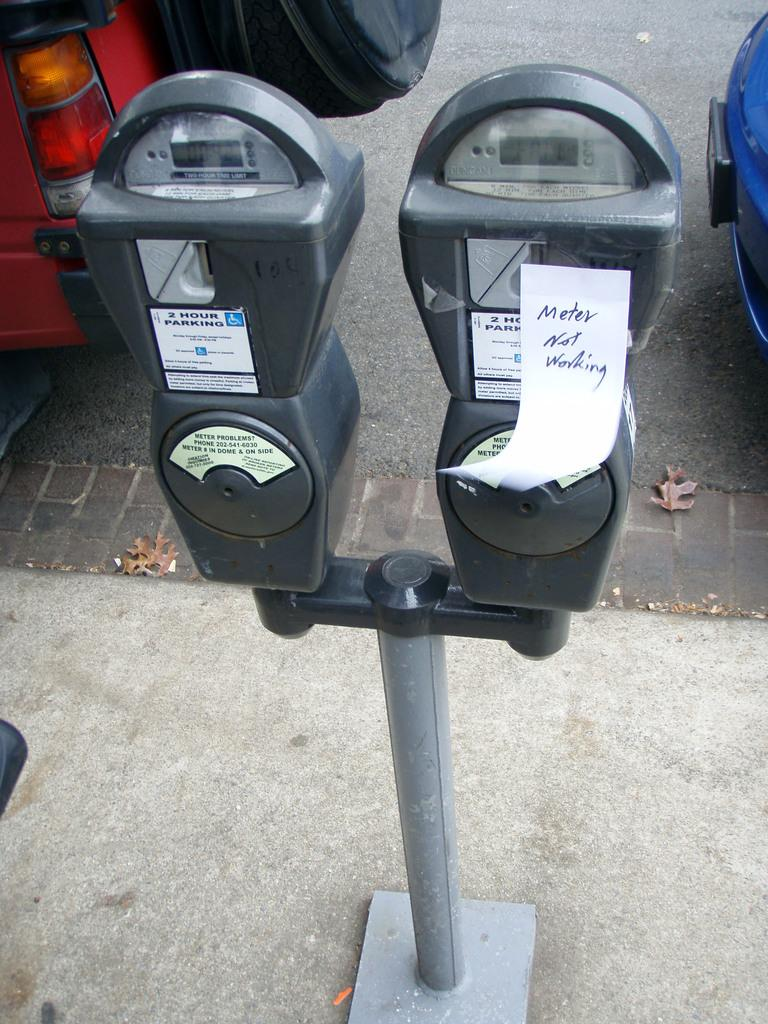<image>
Render a clear and concise summary of the photo. Car meters with a white paper that says Meter Not Working. 